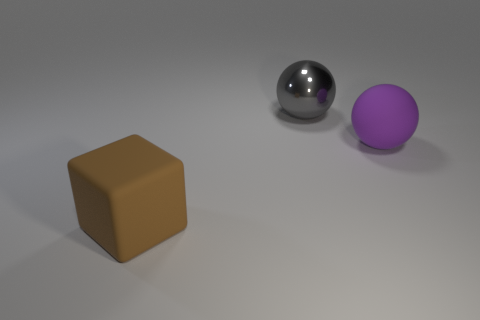Subtract all spheres. How many objects are left? 1 Subtract all purple spheres. How many spheres are left? 1 Add 3 gray balls. How many objects exist? 6 Subtract 0 blue balls. How many objects are left? 3 Subtract 1 balls. How many balls are left? 1 Subtract all blue blocks. Subtract all gray balls. How many blocks are left? 1 Subtract all gray blocks. How many gray balls are left? 1 Subtract all blue rubber blocks. Subtract all big brown rubber cubes. How many objects are left? 2 Add 3 big purple objects. How many big purple objects are left? 4 Add 2 brown matte cubes. How many brown matte cubes exist? 3 